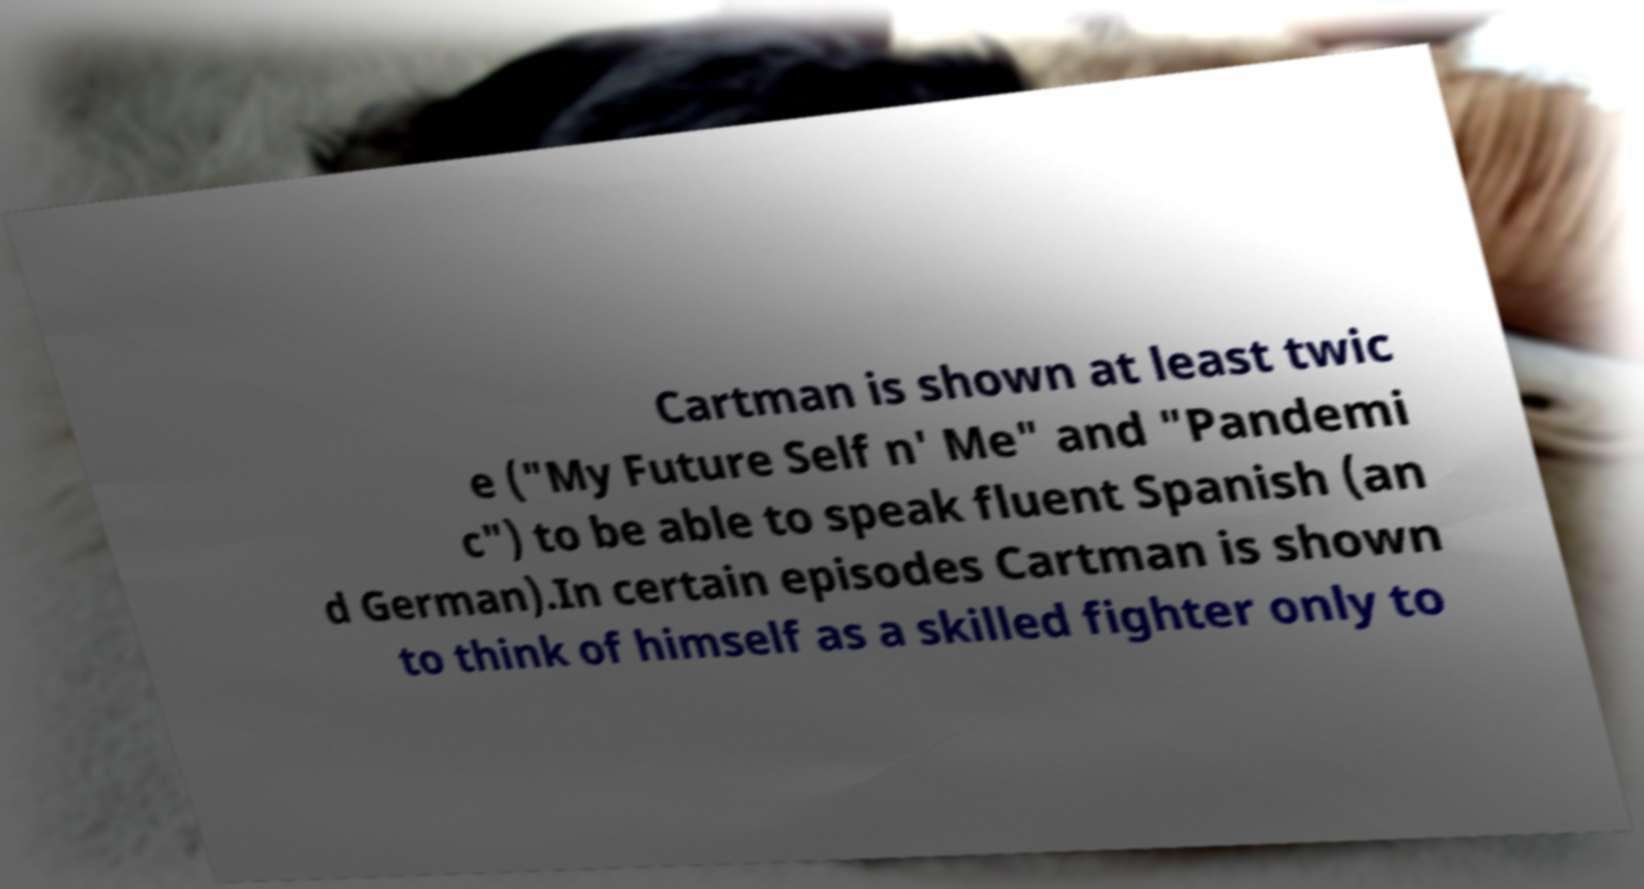Could you assist in decoding the text presented in this image and type it out clearly? Cartman is shown at least twic e ("My Future Self n' Me" and "Pandemi c") to be able to speak fluent Spanish (an d German).In certain episodes Cartman is shown to think of himself as a skilled fighter only to 